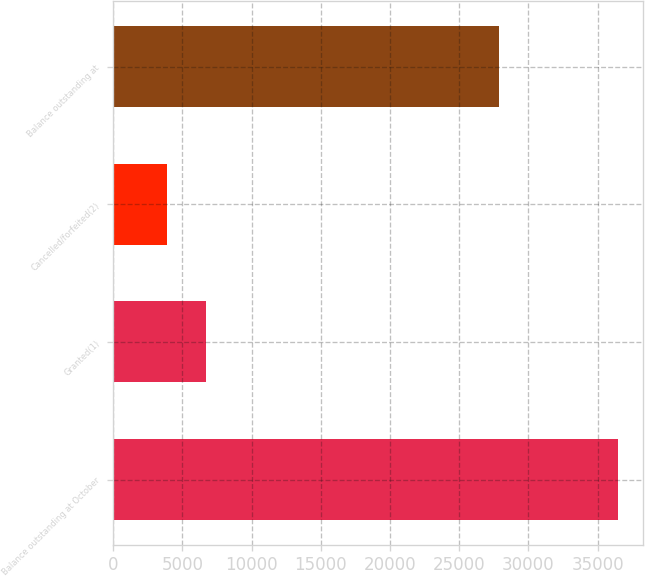<chart> <loc_0><loc_0><loc_500><loc_500><bar_chart><fcel>Balance outstanding at October<fcel>Granted(1)<fcel>Cancelled/forfeited(2)<fcel>Balance outstanding at<nl><fcel>36447<fcel>6702.5<fcel>3918<fcel>27868<nl></chart> 